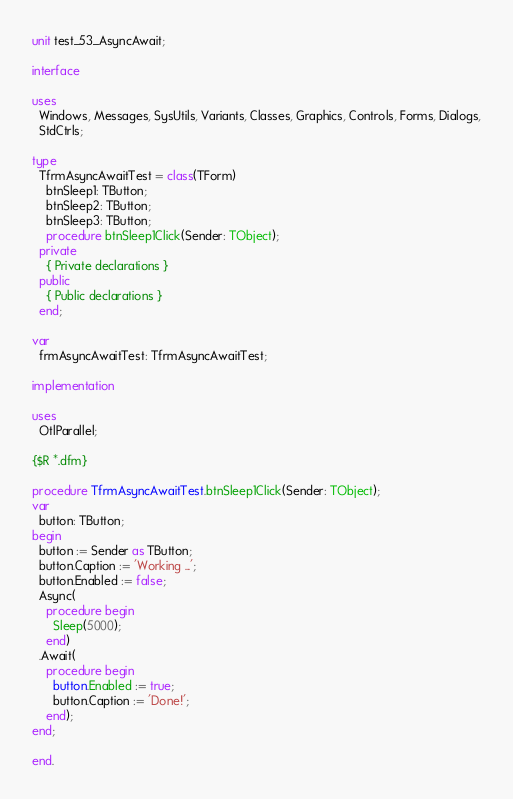Convert code to text. <code><loc_0><loc_0><loc_500><loc_500><_Pascal_>unit test_53_AsyncAwait;

interface

uses
  Windows, Messages, SysUtils, Variants, Classes, Graphics, Controls, Forms, Dialogs,
  StdCtrls;

type
  TfrmAsyncAwaitTest = class(TForm)
    btnSleep1: TButton;
    btnSleep2: TButton;
    btnSleep3: TButton;
    procedure btnSleep1Click(Sender: TObject);
  private
    { Private declarations }
  public
    { Public declarations }
  end;

var
  frmAsyncAwaitTest: TfrmAsyncAwaitTest;

implementation

uses
  OtlParallel;

{$R *.dfm}

procedure TfrmAsyncAwaitTest.btnSleep1Click(Sender: TObject);
var
  button: TButton;
begin
  button := Sender as TButton;
  button.Caption := 'Working ...';
  button.Enabled := false;
  Async(
    procedure begin
      Sleep(5000);
    end)
  .Await(
    procedure begin
      button.Enabled := true;
      button.Caption := 'Done!';
    end);
end;

end.
</code> 